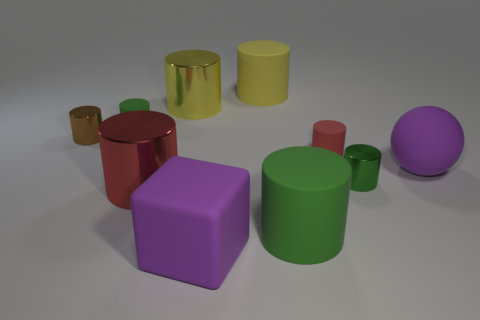Subtract all gray blocks. How many green cylinders are left? 3 Subtract all tiny red matte cylinders. How many cylinders are left? 7 Subtract all red cylinders. How many cylinders are left? 6 Subtract all cyan cylinders. Subtract all purple cubes. How many cylinders are left? 8 Subtract all cylinders. How many objects are left? 2 Subtract all big green rubber objects. Subtract all red objects. How many objects are left? 7 Add 5 tiny green rubber objects. How many tiny green rubber objects are left? 6 Add 4 purple rubber blocks. How many purple rubber blocks exist? 5 Subtract 2 green cylinders. How many objects are left? 8 